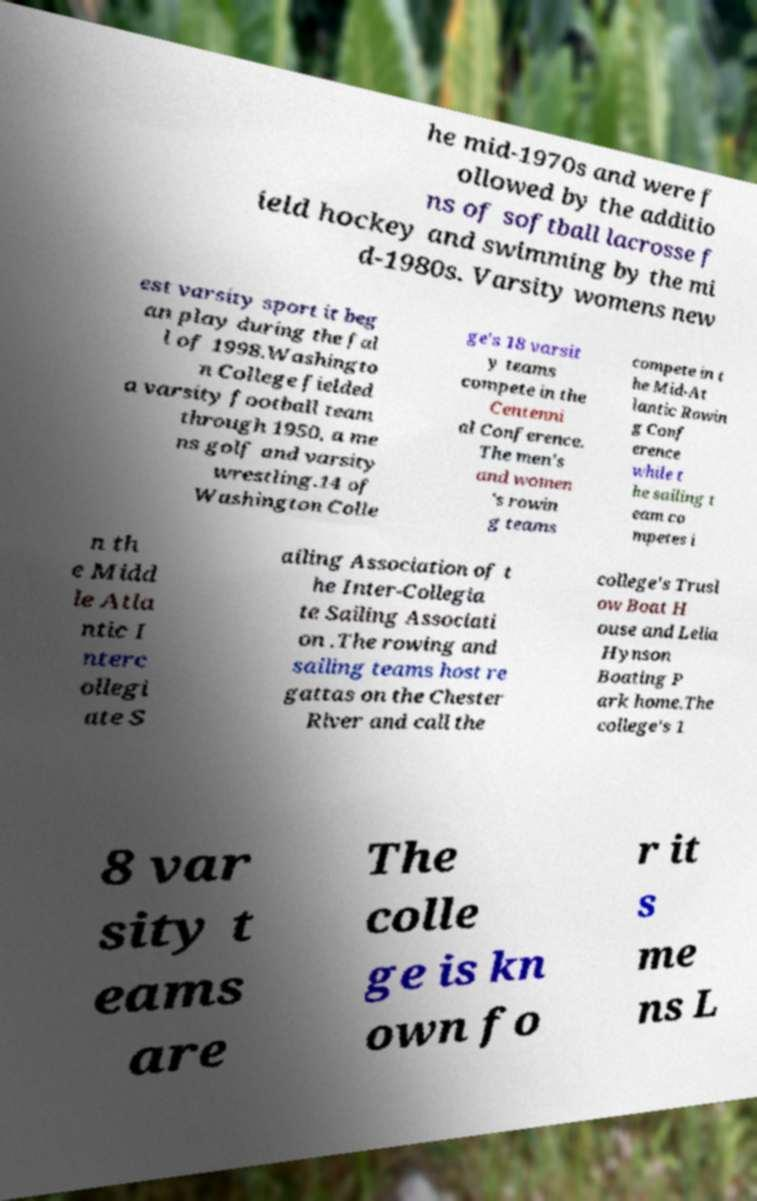Can you read and provide the text displayed in the image?This photo seems to have some interesting text. Can you extract and type it out for me? he mid-1970s and were f ollowed by the additio ns of softball lacrosse f ield hockey and swimming by the mi d-1980s. Varsity womens new est varsity sport it beg an play during the fal l of 1998.Washingto n College fielded a varsity football team through 1950, a me ns golf and varsity wrestling.14 of Washington Colle ge's 18 varsit y teams compete in the Centenni al Conference. The men's and women 's rowin g teams compete in t he Mid-At lantic Rowin g Conf erence while t he sailing t eam co mpetes i n th e Midd le Atla ntic I nterc ollegi ate S ailing Association of t he Inter-Collegia te Sailing Associati on .The rowing and sailing teams host re gattas on the Chester River and call the college's Trusl ow Boat H ouse and Lelia Hynson Boating P ark home.The college's 1 8 var sity t eams are The colle ge is kn own fo r it s me ns L 